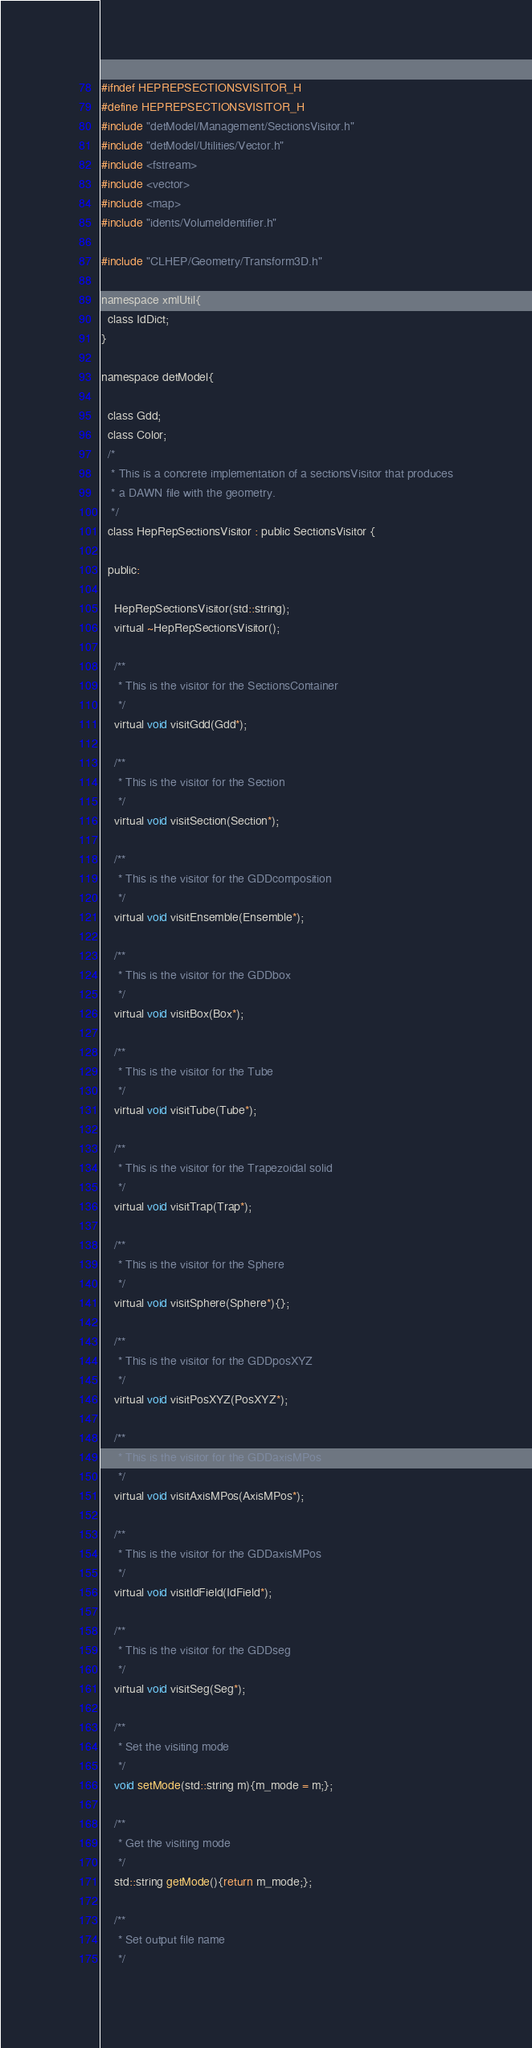<code> <loc_0><loc_0><loc_500><loc_500><_C_>#ifndef HEPREPSECTIONSVISITOR_H
#define HEPREPSECTIONSVISITOR_H
#include "detModel/Management/SectionsVisitor.h"
#include "detModel/Utilities/Vector.h"
#include <fstream>
#include <vector>
#include <map>
#include "idents/VolumeIdentifier.h"

#include "CLHEP/Geometry/Transform3D.h"

namespace xmlUtil{
  class IdDict;
}

namespace detModel{

  class Gdd;
  class Color;
  /*
   * This is a concrete implementation of a sectionsVisitor that produces
   * a DAWN file with the geometry. 
   */
  class HepRepSectionsVisitor : public SectionsVisitor {
    
  public:
    
    HepRepSectionsVisitor(std::string);
    virtual ~HepRepSectionsVisitor();
    
    /**
     * This is the visitor for the SectionsContainer 
     */
    virtual void visitGdd(Gdd*);
    
    /**
     * This is the visitor for the Section 
     */
    virtual void visitSection(Section*);
    
    /**
     * This is the visitor for the GDDcomposition 
     */
    virtual void visitEnsemble(Ensemble*);
    
    /**
     * This is the visitor for the GDDbox 
     */
    virtual void visitBox(Box*);

    /**
     * This is the visitor for the Tube 
     */
    virtual void visitTube(Tube*);

    /**
     * This is the visitor for the Trapezoidal solid
     */
    virtual void visitTrap(Trap*);

    /**
     * This is the visitor for the Sphere 
     */
    virtual void visitSphere(Sphere*){};
    
    /**
     * This is the visitor for the GDDposXYZ 
     */
    virtual void visitPosXYZ(PosXYZ*);
    
    /**
     * This is the visitor for the GDDaxisMPos 
     */
    virtual void visitAxisMPos(AxisMPos*);
    
    /**
     * This is the visitor for the GDDaxisMPos 
     */
    virtual void visitIdField(IdField*);
    
    /**
     * This is the visitor for the GDDseg 
     */
    virtual void visitSeg(Seg*);

    /**
     * Set the visiting mode
     */
    void setMode(std::string m){m_mode = m;};

    /**
     * Get the visiting mode
     */
    std::string getMode(){return m_mode;};

    /**
     * Set output file name
     */</code> 